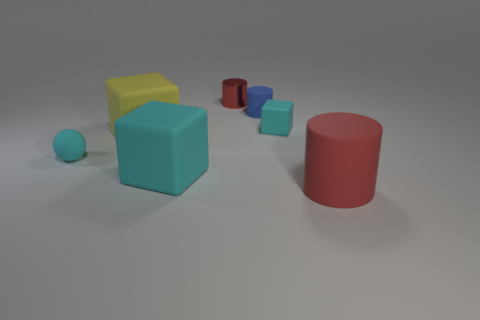Subtract all blue cylinders. How many cyan cubes are left? 2 Subtract all red cylinders. How many cylinders are left? 1 Add 2 cyan objects. How many objects exist? 9 Subtract all yellow blocks. How many blocks are left? 2 Add 6 tiny rubber objects. How many tiny rubber objects exist? 9 Subtract 0 red balls. How many objects are left? 7 Subtract all cylinders. How many objects are left? 4 Subtract all blue cylinders. Subtract all blue balls. How many cylinders are left? 2 Subtract all small gray metal objects. Subtract all large matte cylinders. How many objects are left? 6 Add 3 cyan matte blocks. How many cyan matte blocks are left? 5 